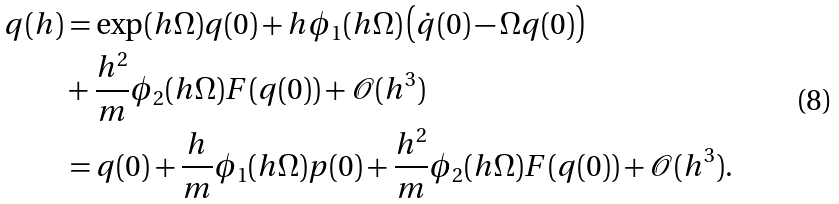<formula> <loc_0><loc_0><loc_500><loc_500>q ( h ) & = \exp ( h \Omega ) q ( 0 ) + h \phi _ { 1 } ( h \Omega ) \left ( \dot { q } ( 0 ) - \Omega q ( 0 ) \right ) \\ & + \frac { h ^ { 2 } } { m } \phi _ { 2 } ( h \Omega ) F ( q ( 0 ) ) + \mathcal { O } ( h ^ { 3 } ) \\ & = q ( 0 ) + \frac { h } { m } \phi _ { 1 } ( h \Omega ) p ( 0 ) + \frac { h ^ { 2 } } { m } \phi _ { 2 } ( h \Omega ) F ( q ( 0 ) ) + \mathcal { O } ( h ^ { 3 } ) .</formula> 